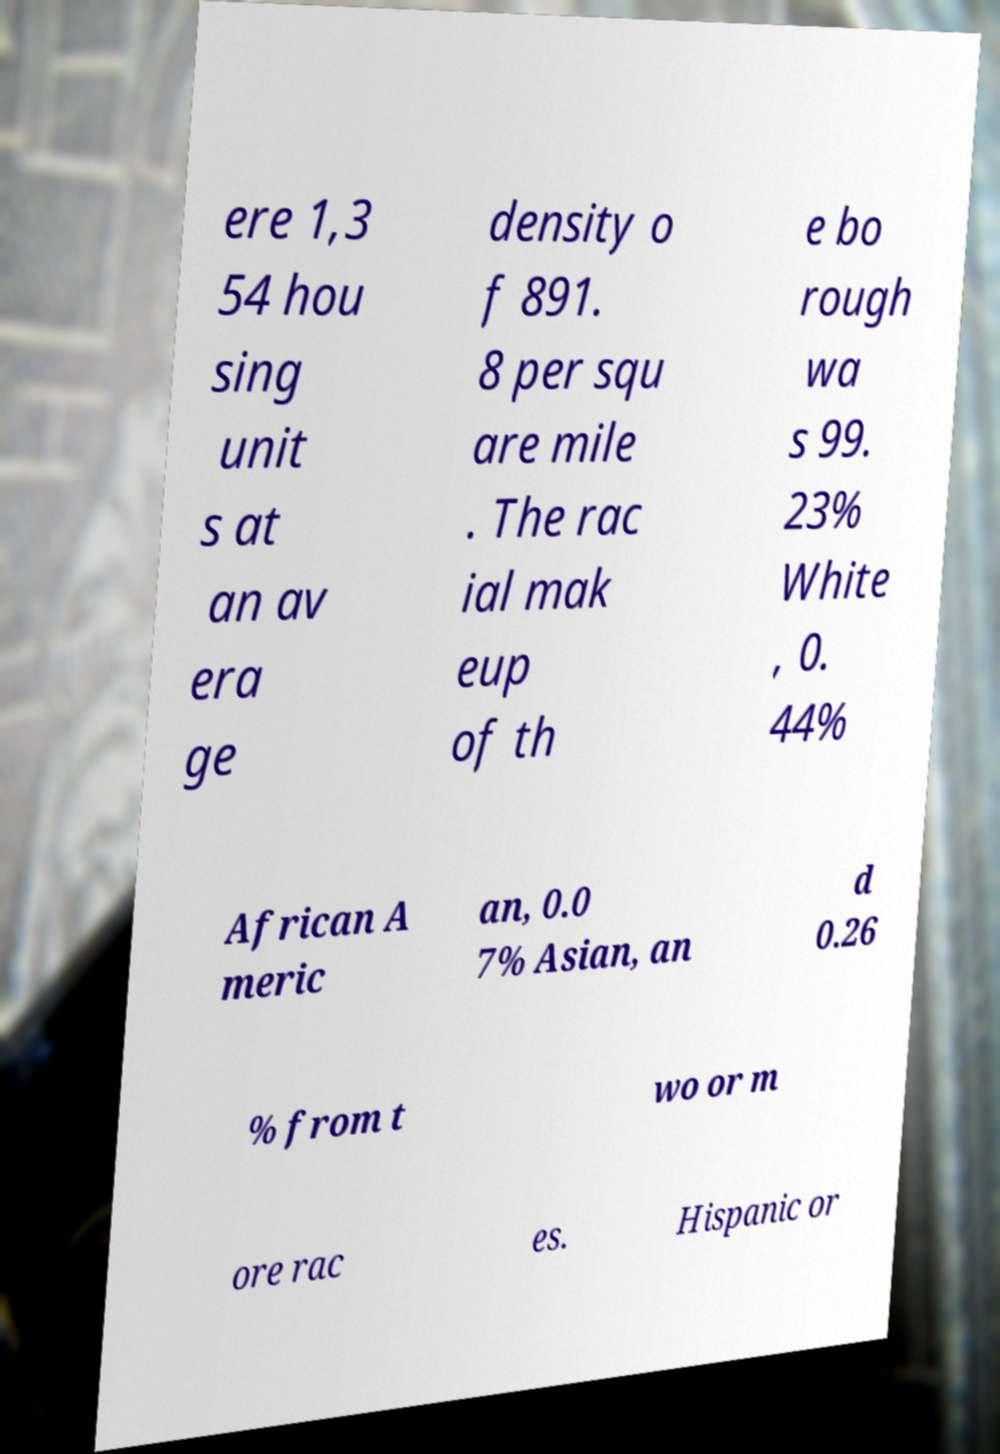Please identify and transcribe the text found in this image. ere 1,3 54 hou sing unit s at an av era ge density o f 891. 8 per squ are mile . The rac ial mak eup of th e bo rough wa s 99. 23% White , 0. 44% African A meric an, 0.0 7% Asian, an d 0.26 % from t wo or m ore rac es. Hispanic or 